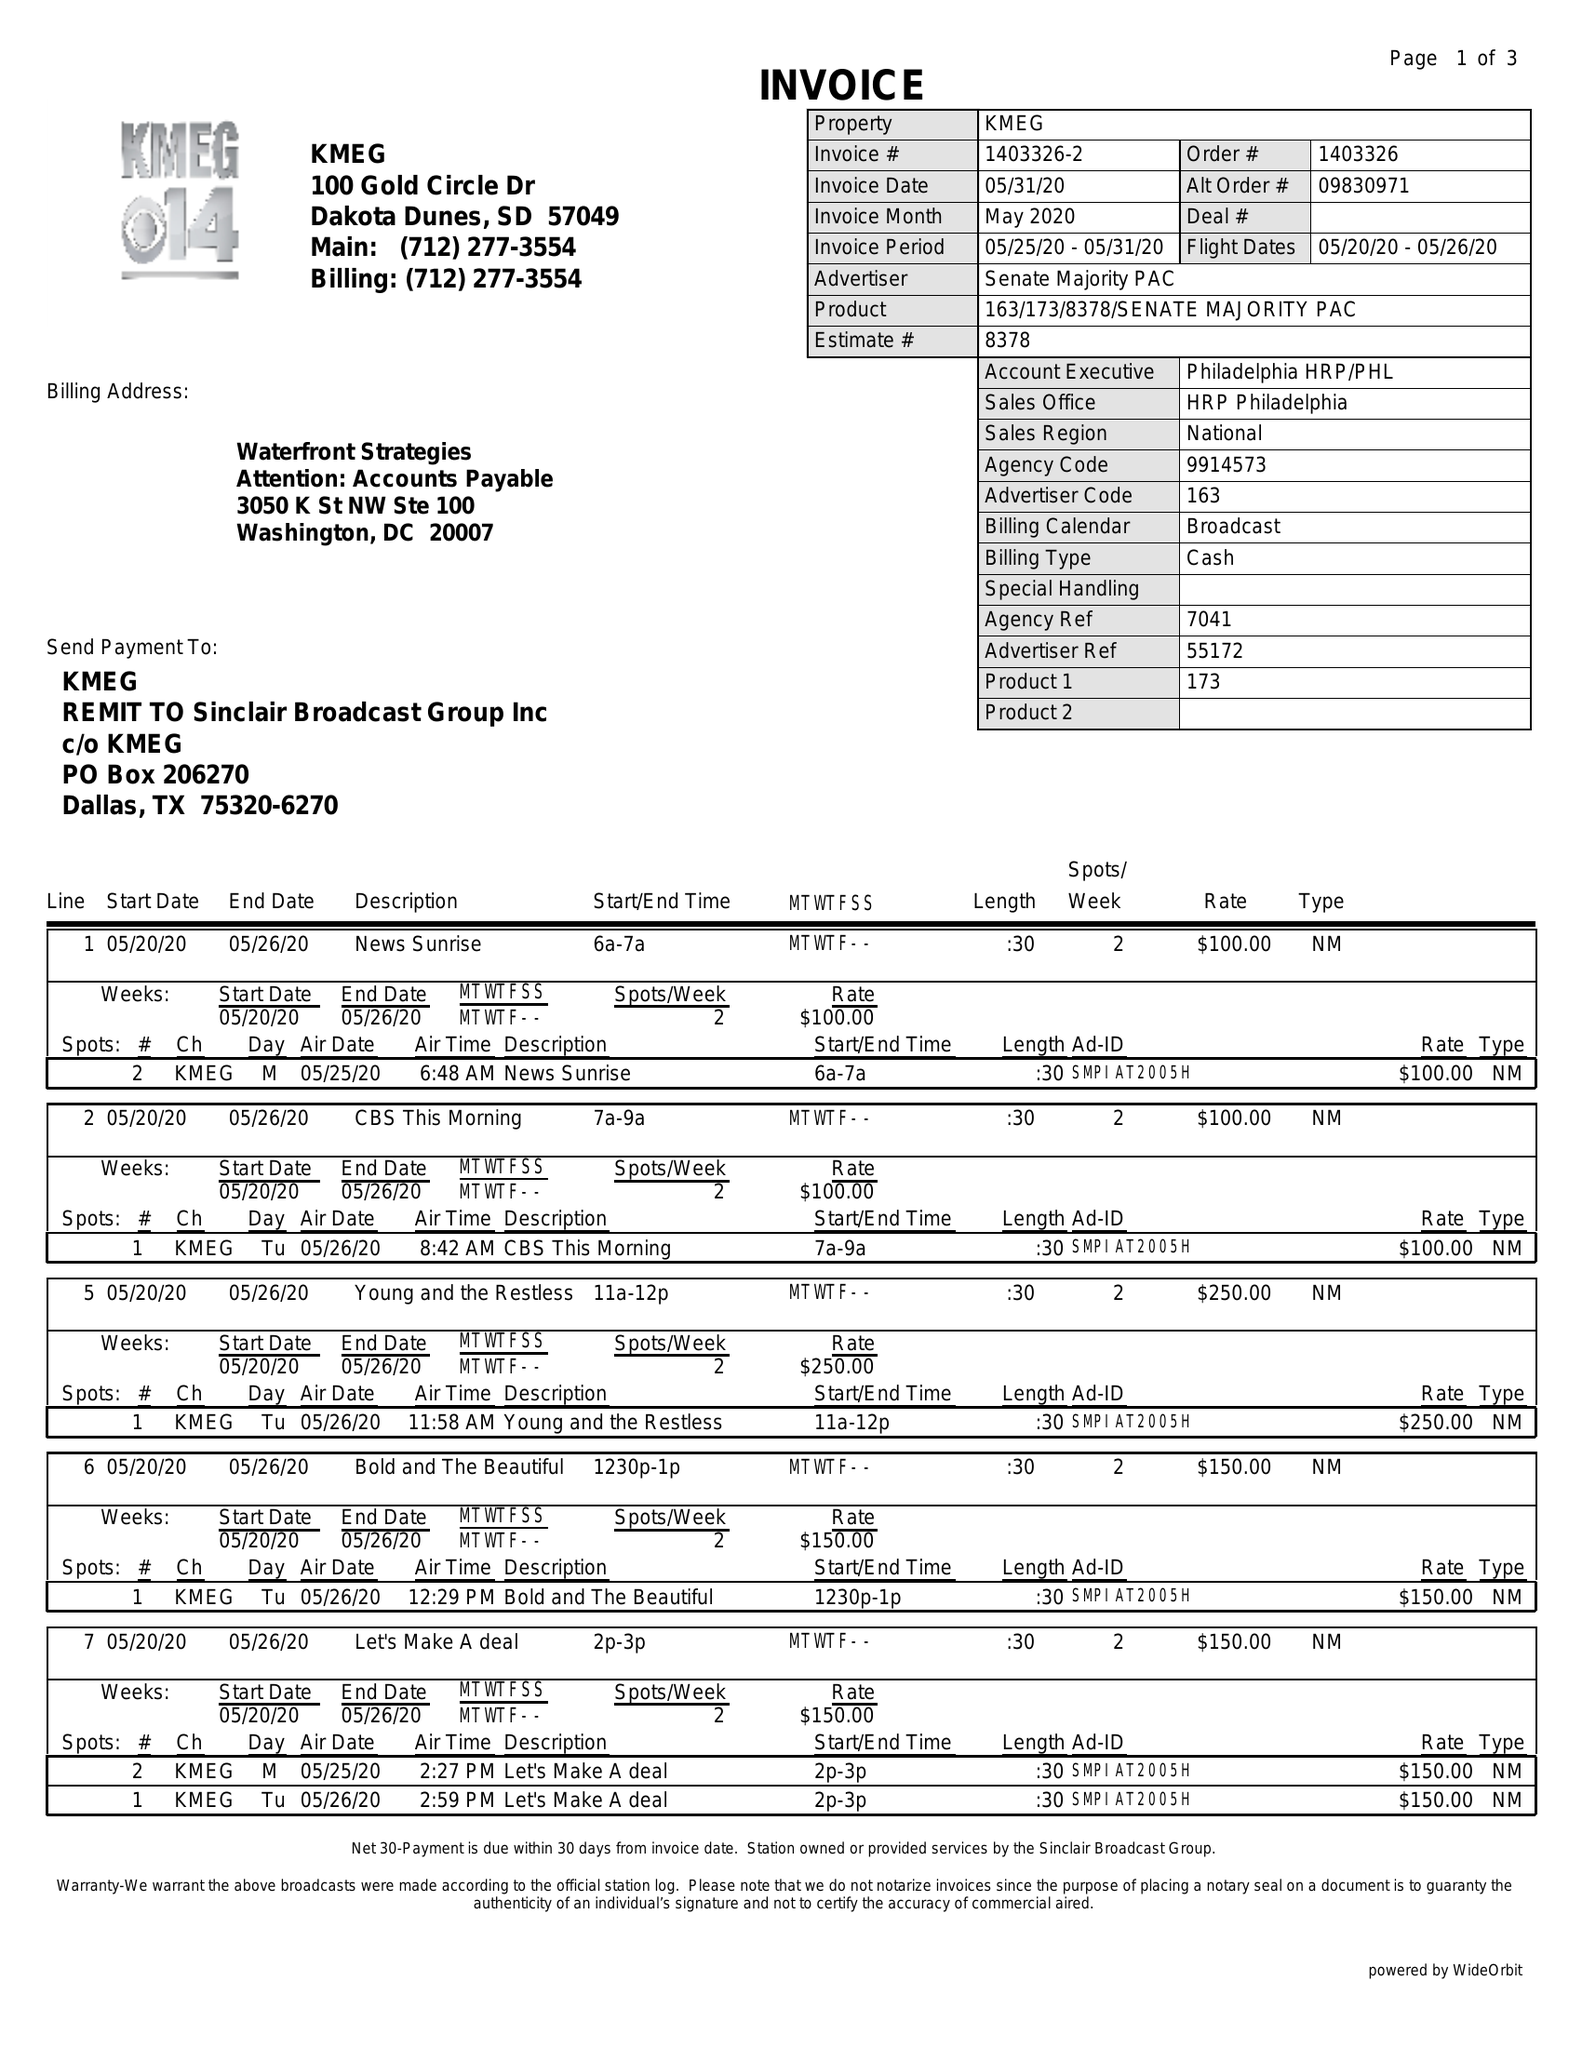What is the value for the gross_amount?
Answer the question using a single word or phrase. 6950.00 